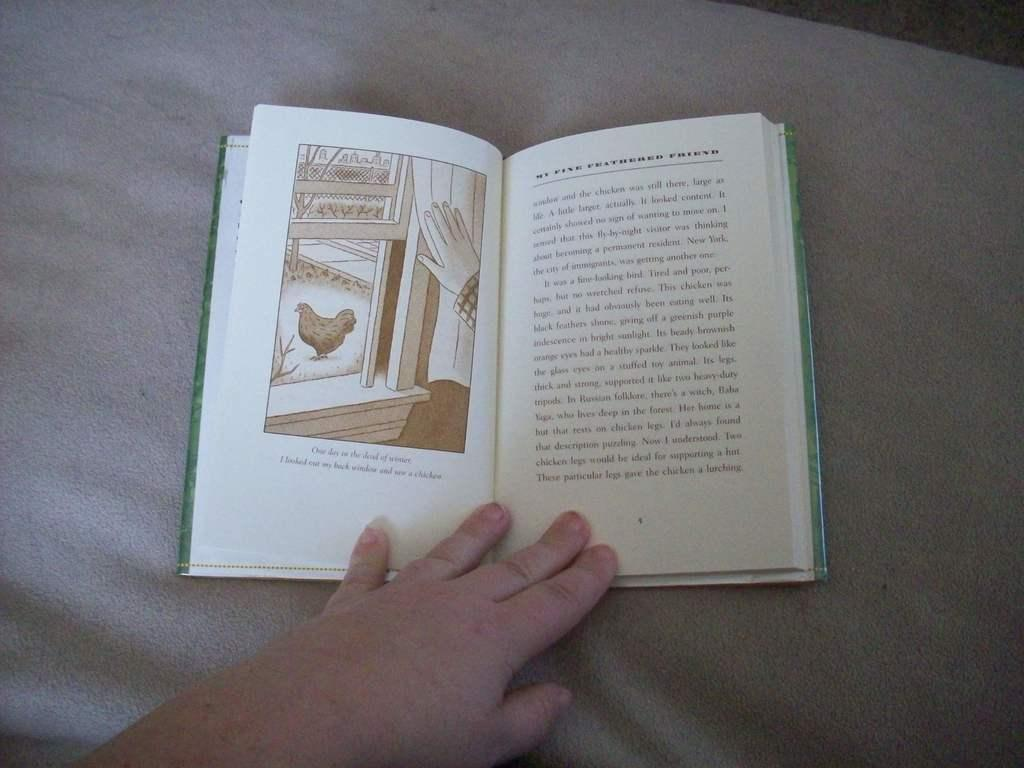<image>
Create a compact narrative representing the image presented. A person holds a book open to a chapter called My Fine Feathered Friend. 